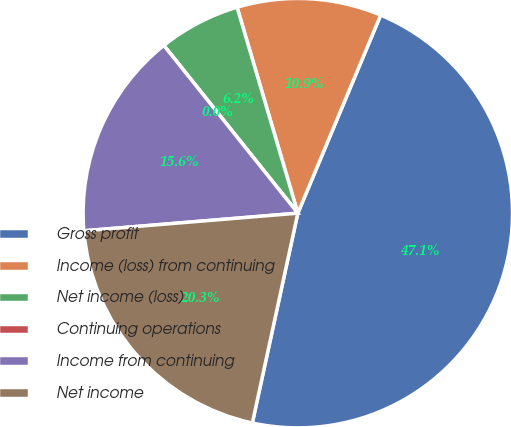Convert chart. <chart><loc_0><loc_0><loc_500><loc_500><pie_chart><fcel>Gross profit<fcel>Income (loss) from continuing<fcel>Net income (loss)<fcel>Continuing operations<fcel>Income from continuing<fcel>Net income<nl><fcel>47.09%<fcel>10.87%<fcel>6.16%<fcel>0.0%<fcel>15.58%<fcel>20.29%<nl></chart> 